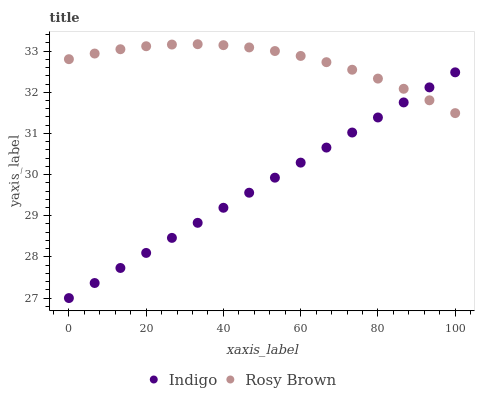Does Indigo have the minimum area under the curve?
Answer yes or no. Yes. Does Rosy Brown have the maximum area under the curve?
Answer yes or no. Yes. Does Indigo have the maximum area under the curve?
Answer yes or no. No. Is Indigo the smoothest?
Answer yes or no. Yes. Is Rosy Brown the roughest?
Answer yes or no. Yes. Is Indigo the roughest?
Answer yes or no. No. Does Indigo have the lowest value?
Answer yes or no. Yes. Does Rosy Brown have the highest value?
Answer yes or no. Yes. Does Indigo have the highest value?
Answer yes or no. No. Does Indigo intersect Rosy Brown?
Answer yes or no. Yes. Is Indigo less than Rosy Brown?
Answer yes or no. No. Is Indigo greater than Rosy Brown?
Answer yes or no. No. 